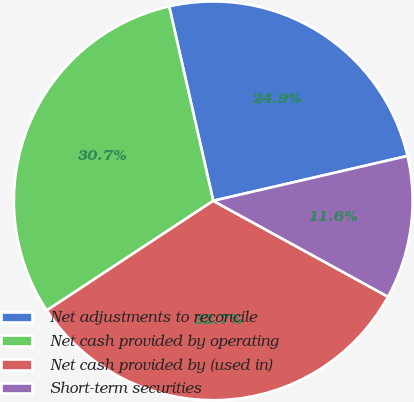Convert chart to OTSL. <chart><loc_0><loc_0><loc_500><loc_500><pie_chart><fcel>Net adjustments to reconcile<fcel>Net cash provided by operating<fcel>Net cash provided by (used in)<fcel>Short-term securities<nl><fcel>24.93%<fcel>30.72%<fcel>32.74%<fcel>11.6%<nl></chart> 